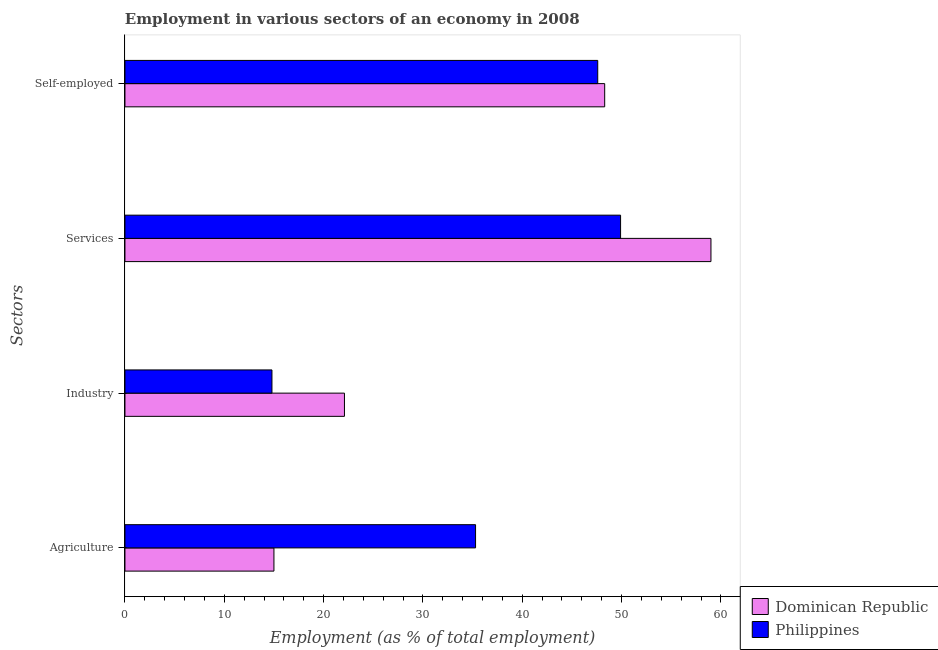How many different coloured bars are there?
Provide a succinct answer. 2. How many groups of bars are there?
Provide a short and direct response. 4. Are the number of bars on each tick of the Y-axis equal?
Keep it short and to the point. Yes. How many bars are there on the 3rd tick from the bottom?
Your response must be concise. 2. What is the label of the 3rd group of bars from the top?
Ensure brevity in your answer.  Industry. What is the percentage of workers in services in Dominican Republic?
Keep it short and to the point. 59. Across all countries, what is the maximum percentage of workers in industry?
Provide a succinct answer. 22.1. Across all countries, what is the minimum percentage of workers in industry?
Keep it short and to the point. 14.8. In which country was the percentage of workers in services maximum?
Your response must be concise. Dominican Republic. In which country was the percentage of workers in services minimum?
Make the answer very short. Philippines. What is the total percentage of self employed workers in the graph?
Make the answer very short. 95.9. What is the difference between the percentage of workers in industry in Dominican Republic and that in Philippines?
Provide a short and direct response. 7.3. What is the difference between the percentage of self employed workers in Dominican Republic and the percentage of workers in industry in Philippines?
Make the answer very short. 33.5. What is the average percentage of self employed workers per country?
Offer a terse response. 47.95. What is the difference between the percentage of workers in agriculture and percentage of self employed workers in Dominican Republic?
Your answer should be compact. -33.3. In how many countries, is the percentage of workers in agriculture greater than 2 %?
Provide a succinct answer. 2. What is the ratio of the percentage of workers in services in Philippines to that in Dominican Republic?
Give a very brief answer. 0.85. Is the percentage of workers in industry in Dominican Republic less than that in Philippines?
Offer a terse response. No. Is the difference between the percentage of workers in services in Philippines and Dominican Republic greater than the difference between the percentage of workers in industry in Philippines and Dominican Republic?
Make the answer very short. No. What is the difference between the highest and the second highest percentage of self employed workers?
Provide a short and direct response. 0.7. What is the difference between the highest and the lowest percentage of workers in agriculture?
Make the answer very short. 20.3. In how many countries, is the percentage of workers in services greater than the average percentage of workers in services taken over all countries?
Your answer should be very brief. 1. What does the 1st bar from the top in Industry represents?
Make the answer very short. Philippines. What does the 1st bar from the bottom in Industry represents?
Your response must be concise. Dominican Republic. How many bars are there?
Provide a succinct answer. 8. How many countries are there in the graph?
Your answer should be very brief. 2. Does the graph contain any zero values?
Keep it short and to the point. No. Where does the legend appear in the graph?
Your response must be concise. Bottom right. How are the legend labels stacked?
Your answer should be compact. Vertical. What is the title of the graph?
Ensure brevity in your answer.  Employment in various sectors of an economy in 2008. What is the label or title of the X-axis?
Offer a very short reply. Employment (as % of total employment). What is the label or title of the Y-axis?
Give a very brief answer. Sectors. What is the Employment (as % of total employment) of Philippines in Agriculture?
Your response must be concise. 35.3. What is the Employment (as % of total employment) in Dominican Republic in Industry?
Your response must be concise. 22.1. What is the Employment (as % of total employment) of Philippines in Industry?
Provide a short and direct response. 14.8. What is the Employment (as % of total employment) in Philippines in Services?
Provide a succinct answer. 49.9. What is the Employment (as % of total employment) in Dominican Republic in Self-employed?
Make the answer very short. 48.3. What is the Employment (as % of total employment) in Philippines in Self-employed?
Provide a succinct answer. 47.6. Across all Sectors, what is the maximum Employment (as % of total employment) of Dominican Republic?
Offer a very short reply. 59. Across all Sectors, what is the maximum Employment (as % of total employment) in Philippines?
Keep it short and to the point. 49.9. Across all Sectors, what is the minimum Employment (as % of total employment) in Dominican Republic?
Your answer should be compact. 15. Across all Sectors, what is the minimum Employment (as % of total employment) in Philippines?
Offer a terse response. 14.8. What is the total Employment (as % of total employment) in Dominican Republic in the graph?
Give a very brief answer. 144.4. What is the total Employment (as % of total employment) in Philippines in the graph?
Offer a terse response. 147.6. What is the difference between the Employment (as % of total employment) in Dominican Republic in Agriculture and that in Industry?
Provide a succinct answer. -7.1. What is the difference between the Employment (as % of total employment) in Philippines in Agriculture and that in Industry?
Your answer should be very brief. 20.5. What is the difference between the Employment (as % of total employment) of Dominican Republic in Agriculture and that in Services?
Provide a succinct answer. -44. What is the difference between the Employment (as % of total employment) of Philippines in Agriculture and that in Services?
Keep it short and to the point. -14.6. What is the difference between the Employment (as % of total employment) of Dominican Republic in Agriculture and that in Self-employed?
Offer a terse response. -33.3. What is the difference between the Employment (as % of total employment) in Philippines in Agriculture and that in Self-employed?
Provide a succinct answer. -12.3. What is the difference between the Employment (as % of total employment) in Dominican Republic in Industry and that in Services?
Your answer should be compact. -36.9. What is the difference between the Employment (as % of total employment) of Philippines in Industry and that in Services?
Give a very brief answer. -35.1. What is the difference between the Employment (as % of total employment) in Dominican Republic in Industry and that in Self-employed?
Keep it short and to the point. -26.2. What is the difference between the Employment (as % of total employment) of Philippines in Industry and that in Self-employed?
Provide a succinct answer. -32.8. What is the difference between the Employment (as % of total employment) in Dominican Republic in Agriculture and the Employment (as % of total employment) in Philippines in Services?
Provide a succinct answer. -34.9. What is the difference between the Employment (as % of total employment) in Dominican Republic in Agriculture and the Employment (as % of total employment) in Philippines in Self-employed?
Your response must be concise. -32.6. What is the difference between the Employment (as % of total employment) of Dominican Republic in Industry and the Employment (as % of total employment) of Philippines in Services?
Your answer should be compact. -27.8. What is the difference between the Employment (as % of total employment) in Dominican Republic in Industry and the Employment (as % of total employment) in Philippines in Self-employed?
Offer a terse response. -25.5. What is the average Employment (as % of total employment) in Dominican Republic per Sectors?
Your response must be concise. 36.1. What is the average Employment (as % of total employment) of Philippines per Sectors?
Offer a very short reply. 36.9. What is the difference between the Employment (as % of total employment) in Dominican Republic and Employment (as % of total employment) in Philippines in Agriculture?
Your answer should be compact. -20.3. What is the difference between the Employment (as % of total employment) in Dominican Republic and Employment (as % of total employment) in Philippines in Industry?
Your answer should be compact. 7.3. What is the difference between the Employment (as % of total employment) in Dominican Republic and Employment (as % of total employment) in Philippines in Services?
Make the answer very short. 9.1. What is the ratio of the Employment (as % of total employment) in Dominican Republic in Agriculture to that in Industry?
Ensure brevity in your answer.  0.68. What is the ratio of the Employment (as % of total employment) of Philippines in Agriculture to that in Industry?
Offer a very short reply. 2.39. What is the ratio of the Employment (as % of total employment) of Dominican Republic in Agriculture to that in Services?
Give a very brief answer. 0.25. What is the ratio of the Employment (as % of total employment) in Philippines in Agriculture to that in Services?
Give a very brief answer. 0.71. What is the ratio of the Employment (as % of total employment) in Dominican Republic in Agriculture to that in Self-employed?
Your response must be concise. 0.31. What is the ratio of the Employment (as % of total employment) in Philippines in Agriculture to that in Self-employed?
Provide a succinct answer. 0.74. What is the ratio of the Employment (as % of total employment) in Dominican Republic in Industry to that in Services?
Keep it short and to the point. 0.37. What is the ratio of the Employment (as % of total employment) in Philippines in Industry to that in Services?
Make the answer very short. 0.3. What is the ratio of the Employment (as % of total employment) of Dominican Republic in Industry to that in Self-employed?
Give a very brief answer. 0.46. What is the ratio of the Employment (as % of total employment) in Philippines in Industry to that in Self-employed?
Offer a very short reply. 0.31. What is the ratio of the Employment (as % of total employment) of Dominican Republic in Services to that in Self-employed?
Ensure brevity in your answer.  1.22. What is the ratio of the Employment (as % of total employment) in Philippines in Services to that in Self-employed?
Provide a succinct answer. 1.05. What is the difference between the highest and the second highest Employment (as % of total employment) of Dominican Republic?
Your answer should be very brief. 10.7. What is the difference between the highest and the second highest Employment (as % of total employment) of Philippines?
Your answer should be compact. 2.3. What is the difference between the highest and the lowest Employment (as % of total employment) of Dominican Republic?
Keep it short and to the point. 44. What is the difference between the highest and the lowest Employment (as % of total employment) in Philippines?
Offer a terse response. 35.1. 